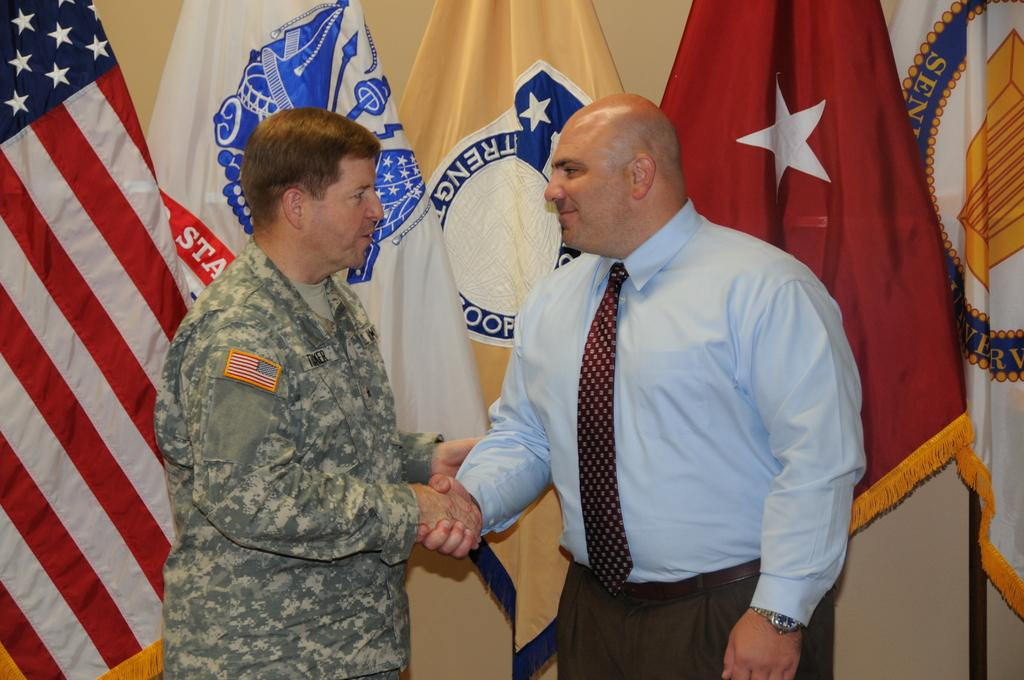How many people are in the image? There are two persons in the image. What are the two persons doing in the image? The two persons are standing and shaking hands. What can be seen in the background of the image? There are different types of flags visible in the background of the image. What type of rabbit can be seen hopping in the image? There is no rabbit present in the image. What is the title of the image? The image does not have a title. 